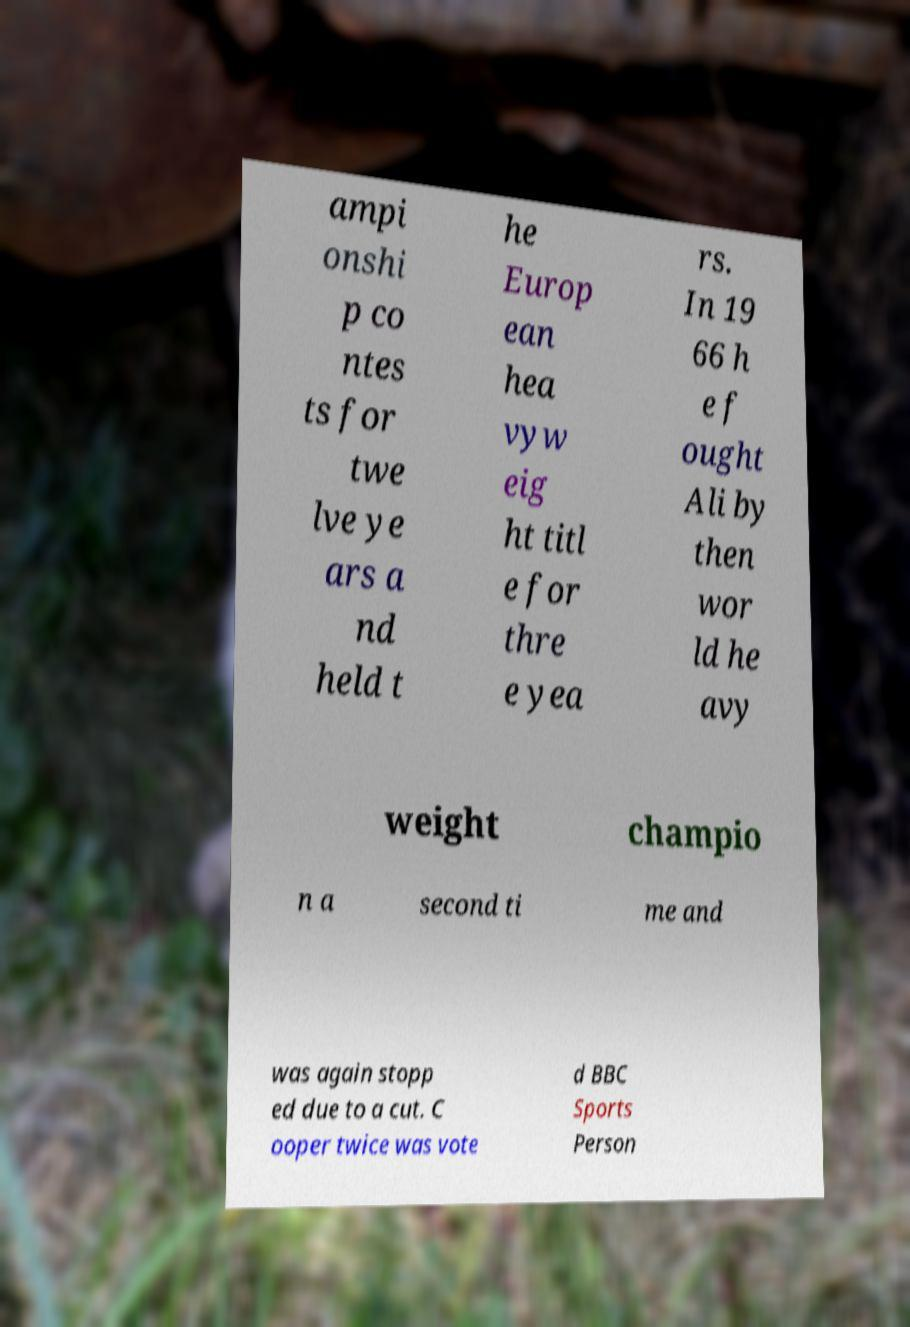What messages or text are displayed in this image? I need them in a readable, typed format. ampi onshi p co ntes ts for twe lve ye ars a nd held t he Europ ean hea vyw eig ht titl e for thre e yea rs. In 19 66 h e f ought Ali by then wor ld he avy weight champio n a second ti me and was again stopp ed due to a cut. C ooper twice was vote d BBC Sports Person 